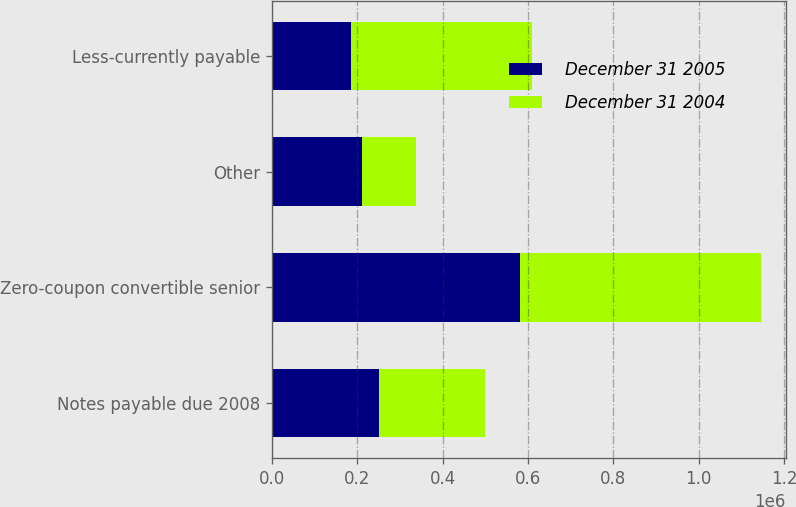Convert chart to OTSL. <chart><loc_0><loc_0><loc_500><loc_500><stacked_bar_chart><ecel><fcel>Notes payable due 2008<fcel>Zero-coupon convertible senior<fcel>Other<fcel>Less-currently payable<nl><fcel>December 31 2005<fcel>250000<fcel>580375<fcel>211347<fcel>183951<nl><fcel>December 31 2004<fcel>250000<fcel>566834<fcel>126664<fcel>424763<nl></chart> 